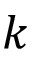Convert formula to latex. <formula><loc_0><loc_0><loc_500><loc_500>k</formula> 